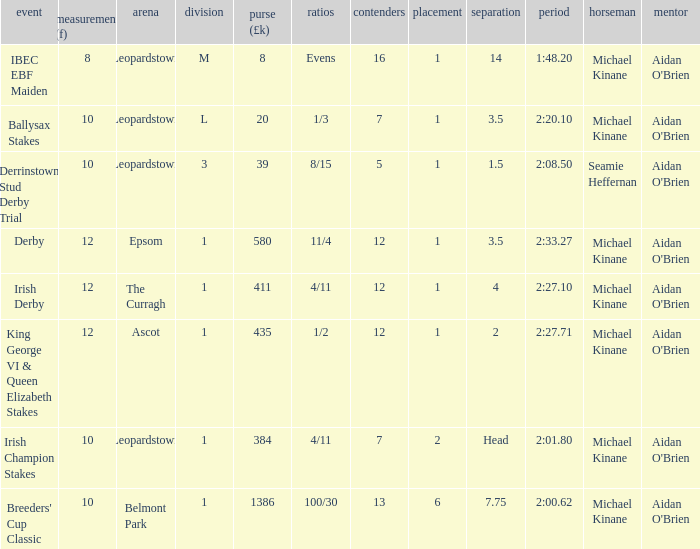Which Dist (f) has a Race of irish derby? 12.0. 